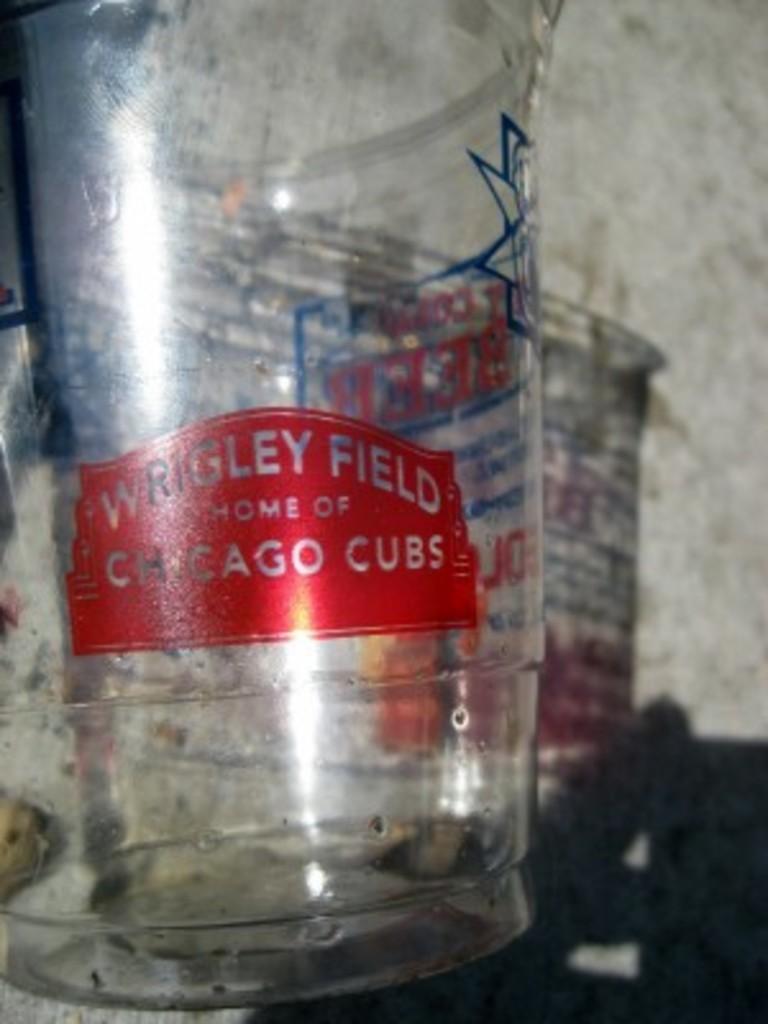What is the name of the field?
Offer a very short reply. Wrigley field. Which team plays at wrigley field?
Your answer should be compact. Chicago cubs. 